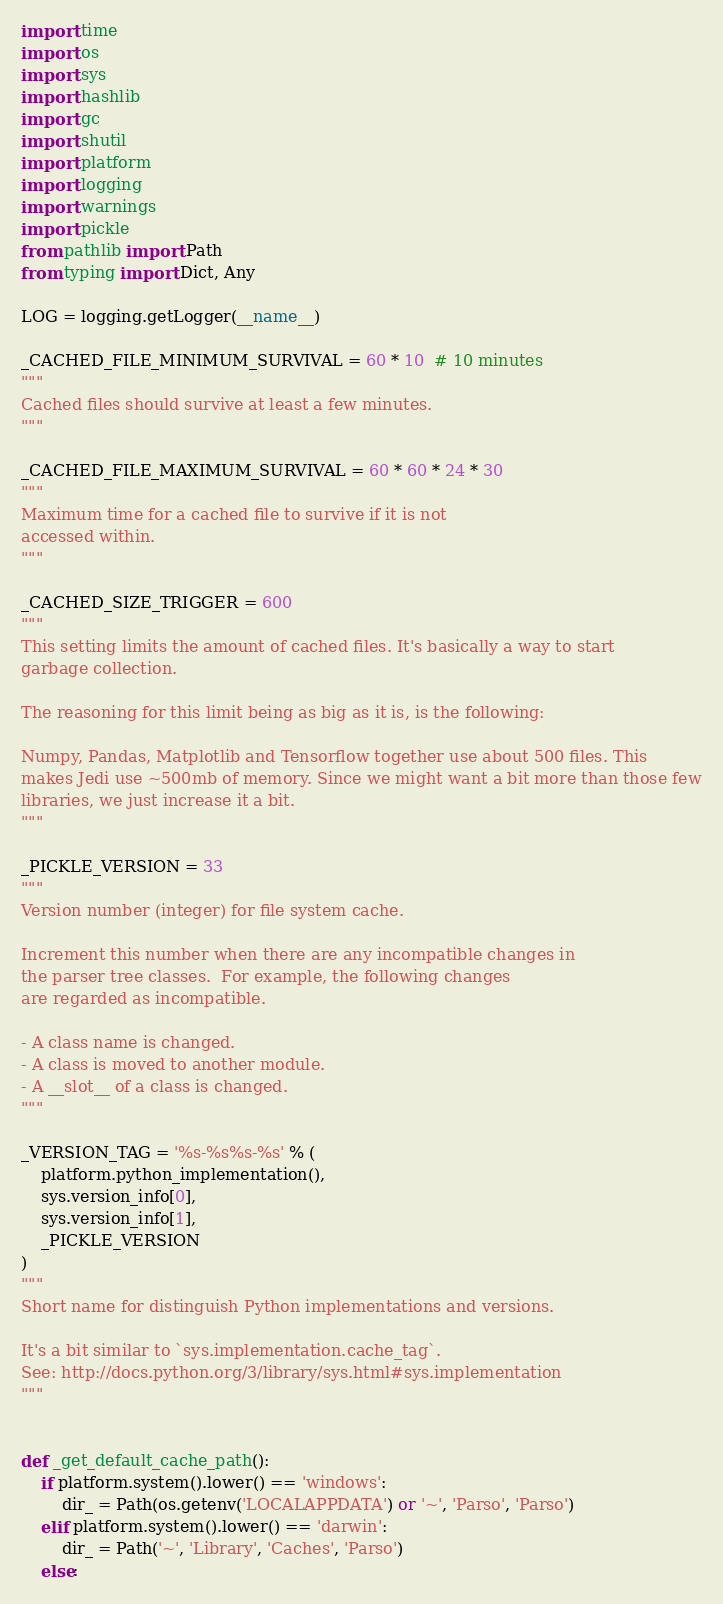<code> <loc_0><loc_0><loc_500><loc_500><_Python_>import time
import os
import sys
import hashlib
import gc
import shutil
import platform
import logging
import warnings
import pickle
from pathlib import Path
from typing import Dict, Any

LOG = logging.getLogger(__name__)

_CACHED_FILE_MINIMUM_SURVIVAL = 60 * 10  # 10 minutes
"""
Cached files should survive at least a few minutes.
"""

_CACHED_FILE_MAXIMUM_SURVIVAL = 60 * 60 * 24 * 30
"""
Maximum time for a cached file to survive if it is not
accessed within.
"""

_CACHED_SIZE_TRIGGER = 600
"""
This setting limits the amount of cached files. It's basically a way to start
garbage collection.

The reasoning for this limit being as big as it is, is the following:

Numpy, Pandas, Matplotlib and Tensorflow together use about 500 files. This
makes Jedi use ~500mb of memory. Since we might want a bit more than those few
libraries, we just increase it a bit.
"""

_PICKLE_VERSION = 33
"""
Version number (integer) for file system cache.

Increment this number when there are any incompatible changes in
the parser tree classes.  For example, the following changes
are regarded as incompatible.

- A class name is changed.
- A class is moved to another module.
- A __slot__ of a class is changed.
"""

_VERSION_TAG = '%s-%s%s-%s' % (
    platform.python_implementation(),
    sys.version_info[0],
    sys.version_info[1],
    _PICKLE_VERSION
)
"""
Short name for distinguish Python implementations and versions.

It's a bit similar to `sys.implementation.cache_tag`.
See: http://docs.python.org/3/library/sys.html#sys.implementation
"""


def _get_default_cache_path():
    if platform.system().lower() == 'windows':
        dir_ = Path(os.getenv('LOCALAPPDATA') or '~', 'Parso', 'Parso')
    elif platform.system().lower() == 'darwin':
        dir_ = Path('~', 'Library', 'Caches', 'Parso')
    else:</code> 